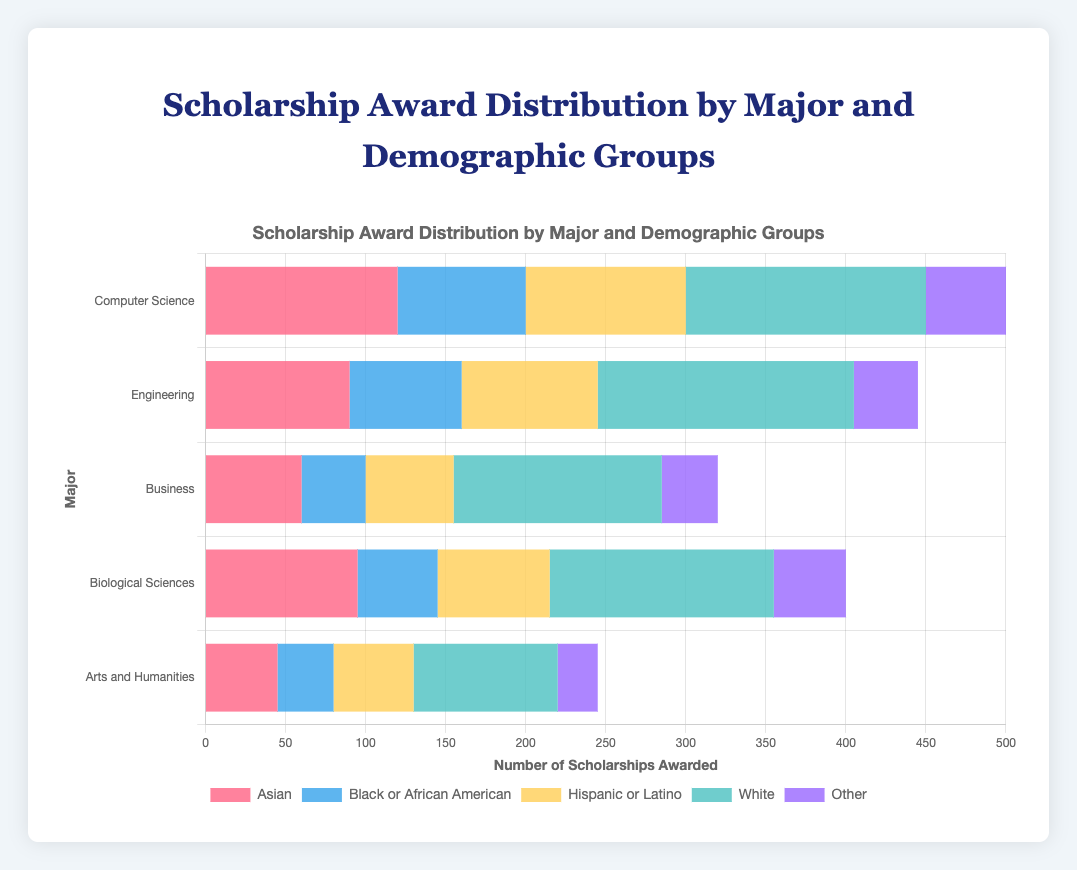Which major and demographic group received the highest number of scholarships? The major is Engineering and the demographic group is White since the length of the corresponding bar is the longest in the figure.
Answer: Engineering, White Which demographic group received fewer scholarships in Business compared to Computer Science? By looking at the visual lengths of the bars for Computer Science and Business, every demographic group received fewer scholarships in Business compared to Computer Science.
Answer: All How many scholarships were awarded to Hispanic or Latino students across all majors? The counts for Hispanic or Latino students are: 100 (Comp Sci) + 85 (Eng) + 55 (Bus) + 70 (Bio Sci) + 50 (Arts). Summing these up yields 360.
Answer: 360 Compare the number of scholarships awarded to Asian students in Biological Sciences and Arts and Humanities. Which is higher? The visual lengths of the bars show 95 scholarships for Asians in Biological Sciences and 45 in Arts and Humanities. Thus, Biological Sciences is higher.
Answer: Biological Sciences What is the total number of scholarships awarded to White students in Science-related majors (Computer Science, Engineering, and Biological Sciences)? Adding the scholarships for White students across these majors: 150 (Comp Sci), 160 (Eng), 140 (Bio Sci) gives 450.
Answer: 450 Estimate the number of scholarships awarded to "Other" demographic in Engineering relative to Hispanic or Latino in the same major. Which group received more? The bars for "Other" and "Hispanic or Latino" in Engineering show 40 and 85 scholarships respectively. Hispanic or Latino received more.
Answer: Hispanic or Latino Identify the major in which Black or African American students received the fewest scholarships. Comparing the visual lengths of the bars for each major, Black or African American students received the fewest scholarships in Arts and Humanities with only 35 awarded.
Answer: Arts and Humanities Determine the average number of scholarships awarded to White students in all majors. Summing up scholarships for White students: 150 (Comp Sci), 160 (Eng), 130 (Bus), 140 (Bio Sci), 90 (Arts), then dividing by 5: (150 + 160 + 130 + 140 + 90) / 5 = 134.
Answer: 134 Compare and find out which major has a more even distribution of scholarships across different demographics. By visual inspection, both Business and Arts and Humanities seem to have a more even distribution among different demographic groups compared to majors like Computer Science.
Answer: Business, Arts and Humanities What percentage of the total scholarships in Engineering were awarded to Asian students? Total in Engineering is: 160 + 90 + 70 + 85 + 40 = 445. Asian students got 90. Percentage = (90 / 445) * 100 ≈ 20.22%.
Answer: ≈ 20.22% 